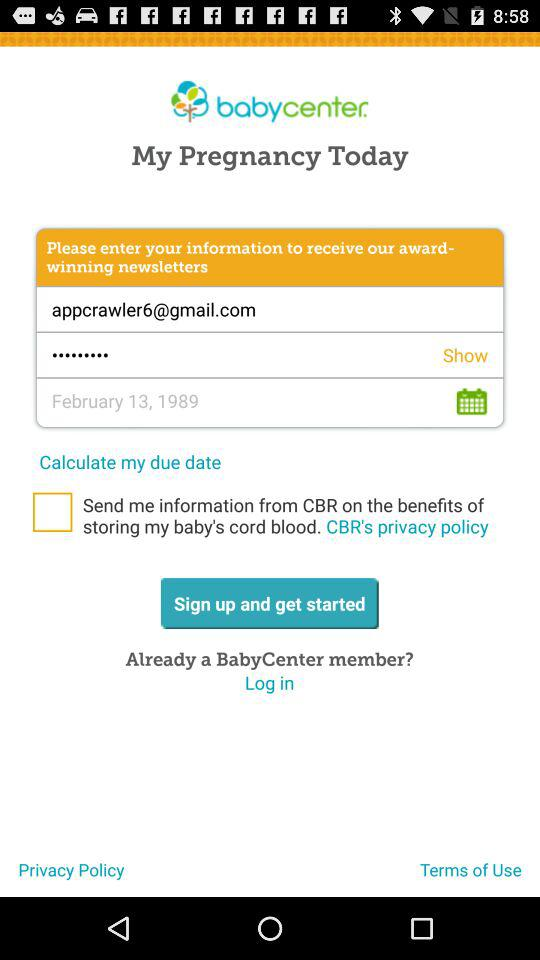What is the selected date? The selected date is February 13, 1989. 